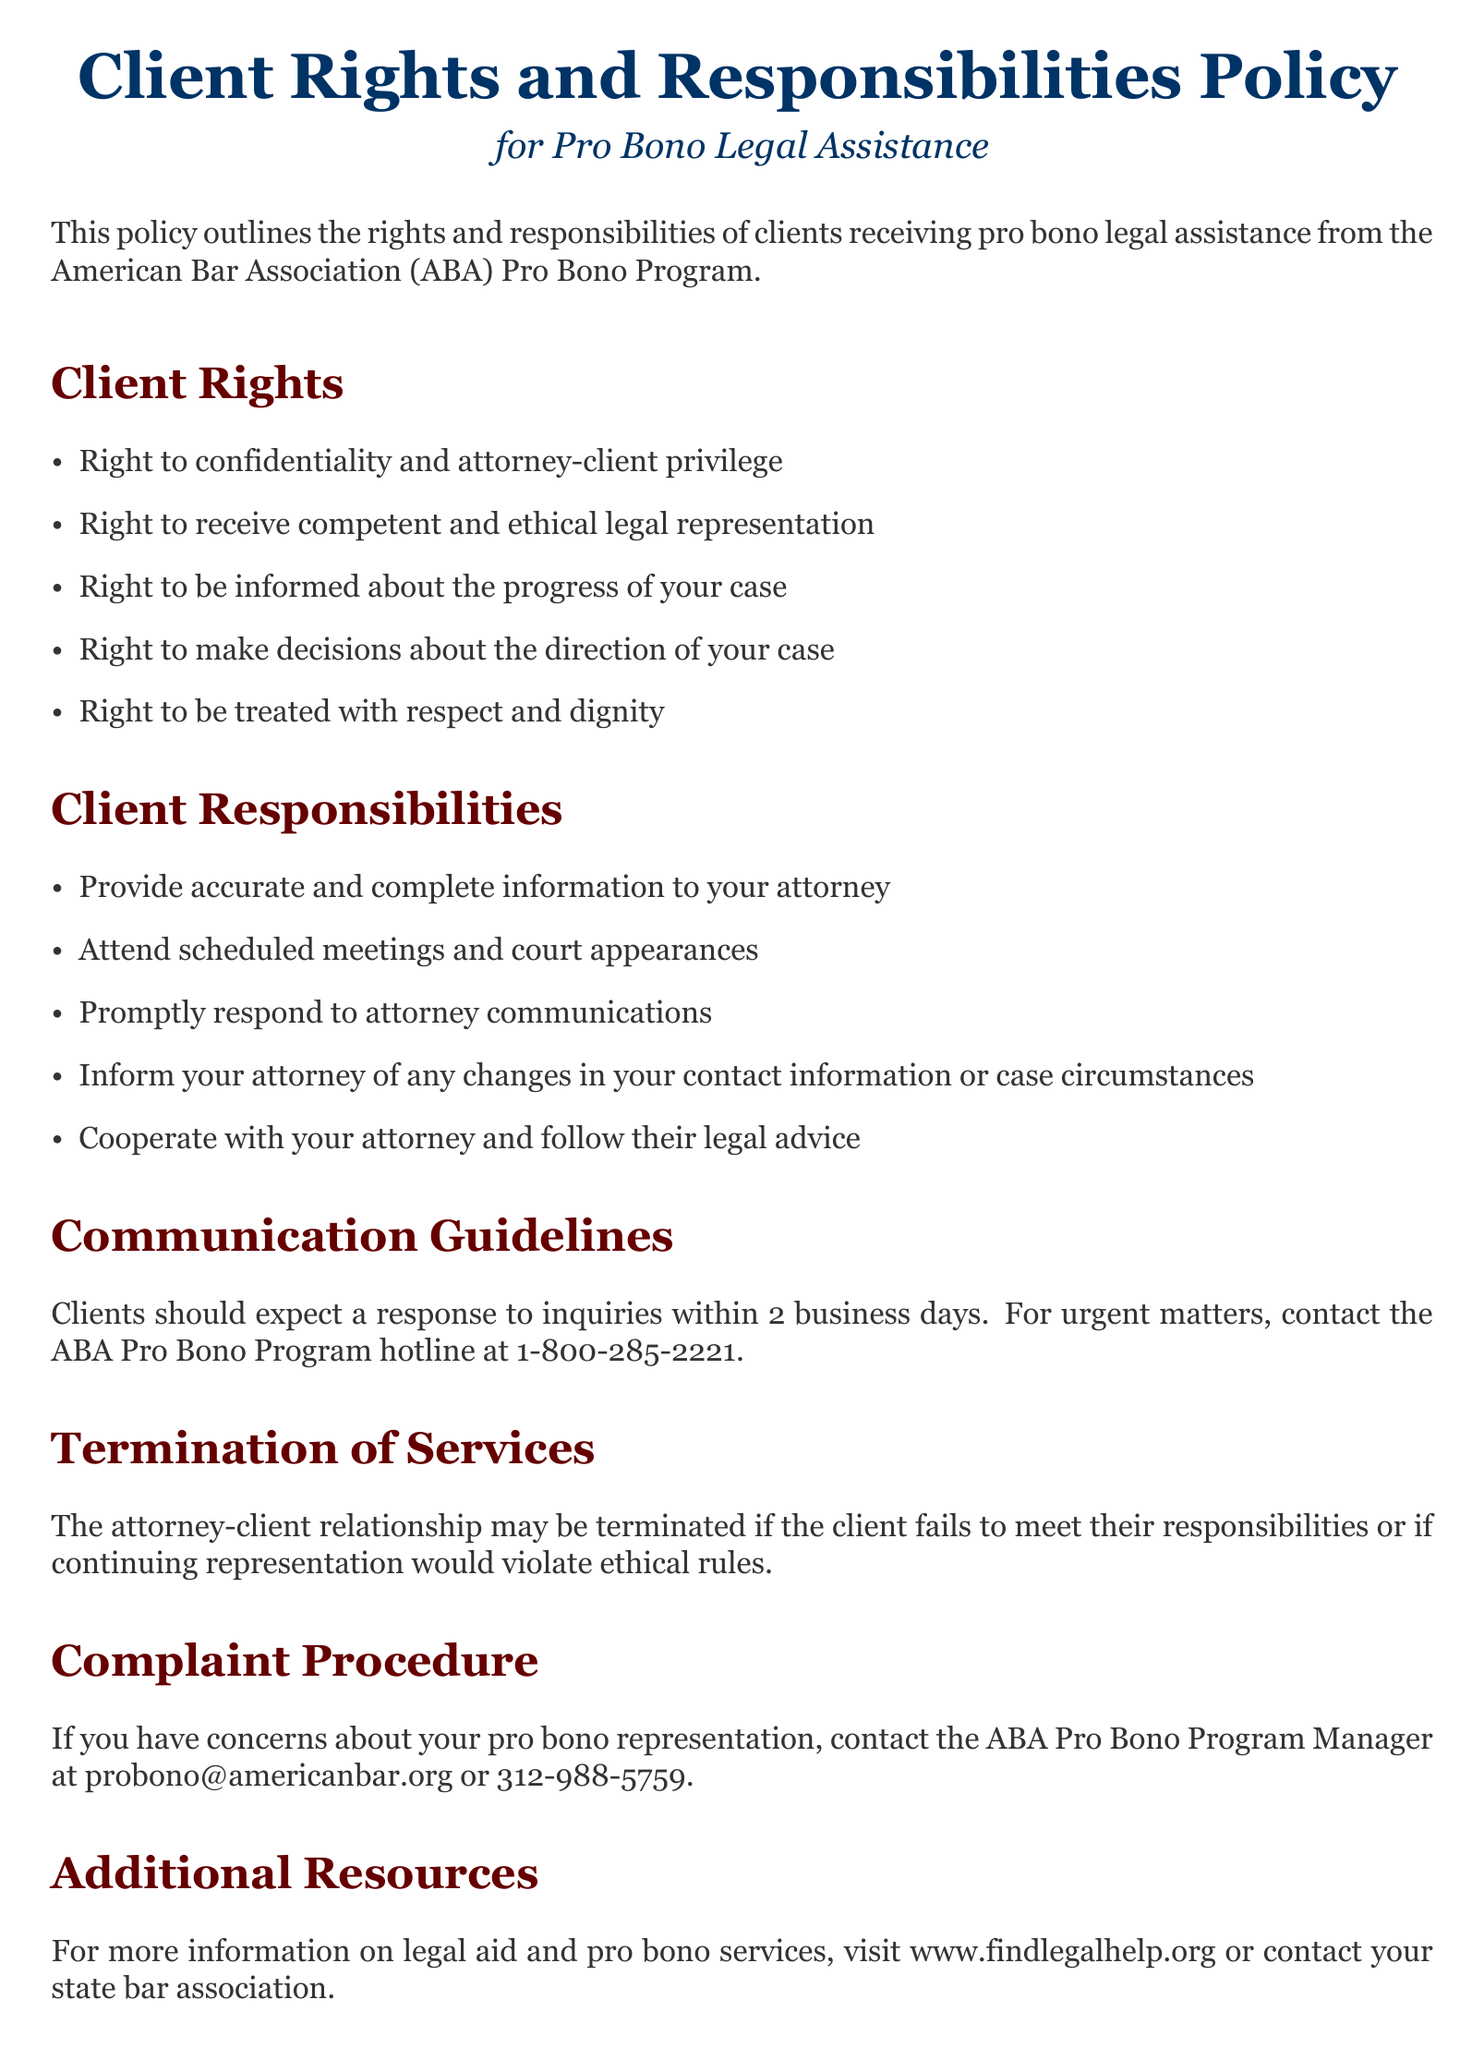What are the rights of clients? The rights of clients include confidentiality, competent representation, progress updates, decision-making, and respect.
Answer: confidentiality and attorney-client privilege, competent and ethical legal representation, be informed about the progress of your case, make decisions about the direction of your case, treated with respect and dignity What should clients provide to their attorney? Clients are responsible for providing accurate and complete information to their attorney.
Answer: accurate and complete information What is the expected response time for inquiries? The document states that clients should expect a response to inquiries within 2 business days.
Answer: 2 business days What is the hotline number for urgent matters? For urgent matters, the document provides a hotline number to contact the ABA Pro Bono Program.
Answer: 1-800-285-2221 What may cause the termination of services? Services may be terminated if the client fails to meet their responsibilities or if representation violates ethical rules.
Answer: client fails to meet their responsibilities or if continuing representation would violate ethical rules Who should clients contact for concerns about representation? Clients can contact the ABA Pro Bono Program Manager to express concerns about their representation.
Answer: ABA Pro Bono Program Manager What is an additional resource mentioned in the document? The document mentions a website where individuals can find more information on legal aid and pro bono services.
Answer: www.findlegalhelp.org 